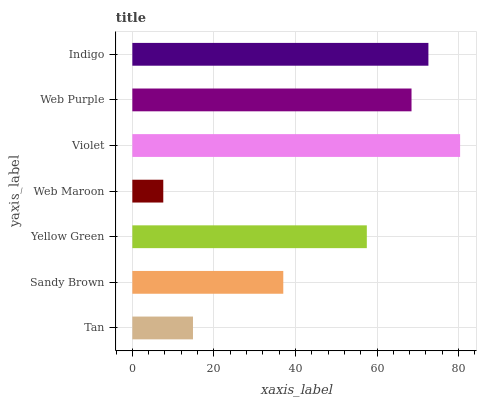Is Web Maroon the minimum?
Answer yes or no. Yes. Is Violet the maximum?
Answer yes or no. Yes. Is Sandy Brown the minimum?
Answer yes or no. No. Is Sandy Brown the maximum?
Answer yes or no. No. Is Sandy Brown greater than Tan?
Answer yes or no. Yes. Is Tan less than Sandy Brown?
Answer yes or no. Yes. Is Tan greater than Sandy Brown?
Answer yes or no. No. Is Sandy Brown less than Tan?
Answer yes or no. No. Is Yellow Green the high median?
Answer yes or no. Yes. Is Yellow Green the low median?
Answer yes or no. Yes. Is Violet the high median?
Answer yes or no. No. Is Web Purple the low median?
Answer yes or no. No. 